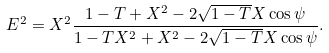<formula> <loc_0><loc_0><loc_500><loc_500>E ^ { 2 } = X ^ { 2 } \frac { 1 - T + X ^ { 2 } - 2 \sqrt { 1 - T } X \cos \psi } { 1 - T X ^ { 2 } + X ^ { 2 } - 2 \sqrt { 1 - T } X \cos \psi } .</formula> 